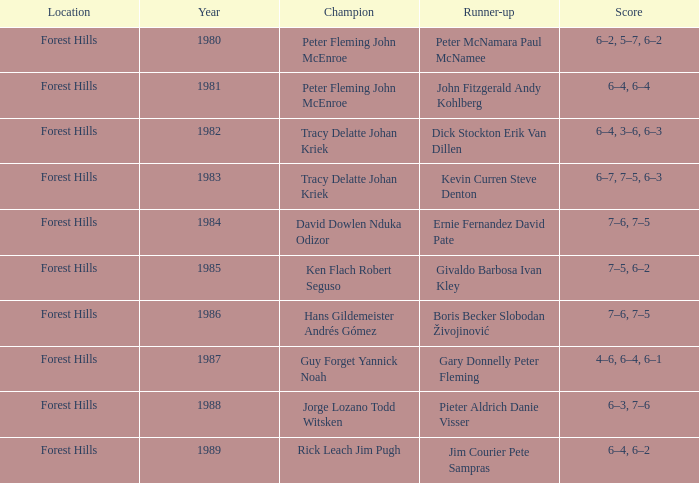Help me parse the entirety of this table. {'header': ['Location', 'Year', 'Champion', 'Runner-up', 'Score'], 'rows': [['Forest Hills', '1980', 'Peter Fleming John McEnroe', 'Peter McNamara Paul McNamee', '6–2, 5–7, 6–2'], ['Forest Hills', '1981', 'Peter Fleming John McEnroe', 'John Fitzgerald Andy Kohlberg', '6–4, 6–4'], ['Forest Hills', '1982', 'Tracy Delatte Johan Kriek', 'Dick Stockton Erik Van Dillen', '6–4, 3–6, 6–3'], ['Forest Hills', '1983', 'Tracy Delatte Johan Kriek', 'Kevin Curren Steve Denton', '6–7, 7–5, 6–3'], ['Forest Hills', '1984', 'David Dowlen Nduka Odizor', 'Ernie Fernandez David Pate', '7–6, 7–5'], ['Forest Hills', '1985', 'Ken Flach Robert Seguso', 'Givaldo Barbosa Ivan Kley', '7–5, 6–2'], ['Forest Hills', '1986', 'Hans Gildemeister Andrés Gómez', 'Boris Becker Slobodan Živojinović', '7–6, 7–5'], ['Forest Hills', '1987', 'Guy Forget Yannick Noah', 'Gary Donnelly Peter Fleming', '4–6, 6–4, 6–1'], ['Forest Hills', '1988', 'Jorge Lozano Todd Witsken', 'Pieter Aldrich Danie Visser', '6–3, 7–6'], ['Forest Hills', '1989', 'Rick Leach Jim Pugh', 'Jim Courier Pete Sampras', '6–4, 6–2']]} Who were the winners in 1988? Jorge Lozano Todd Witsken. 